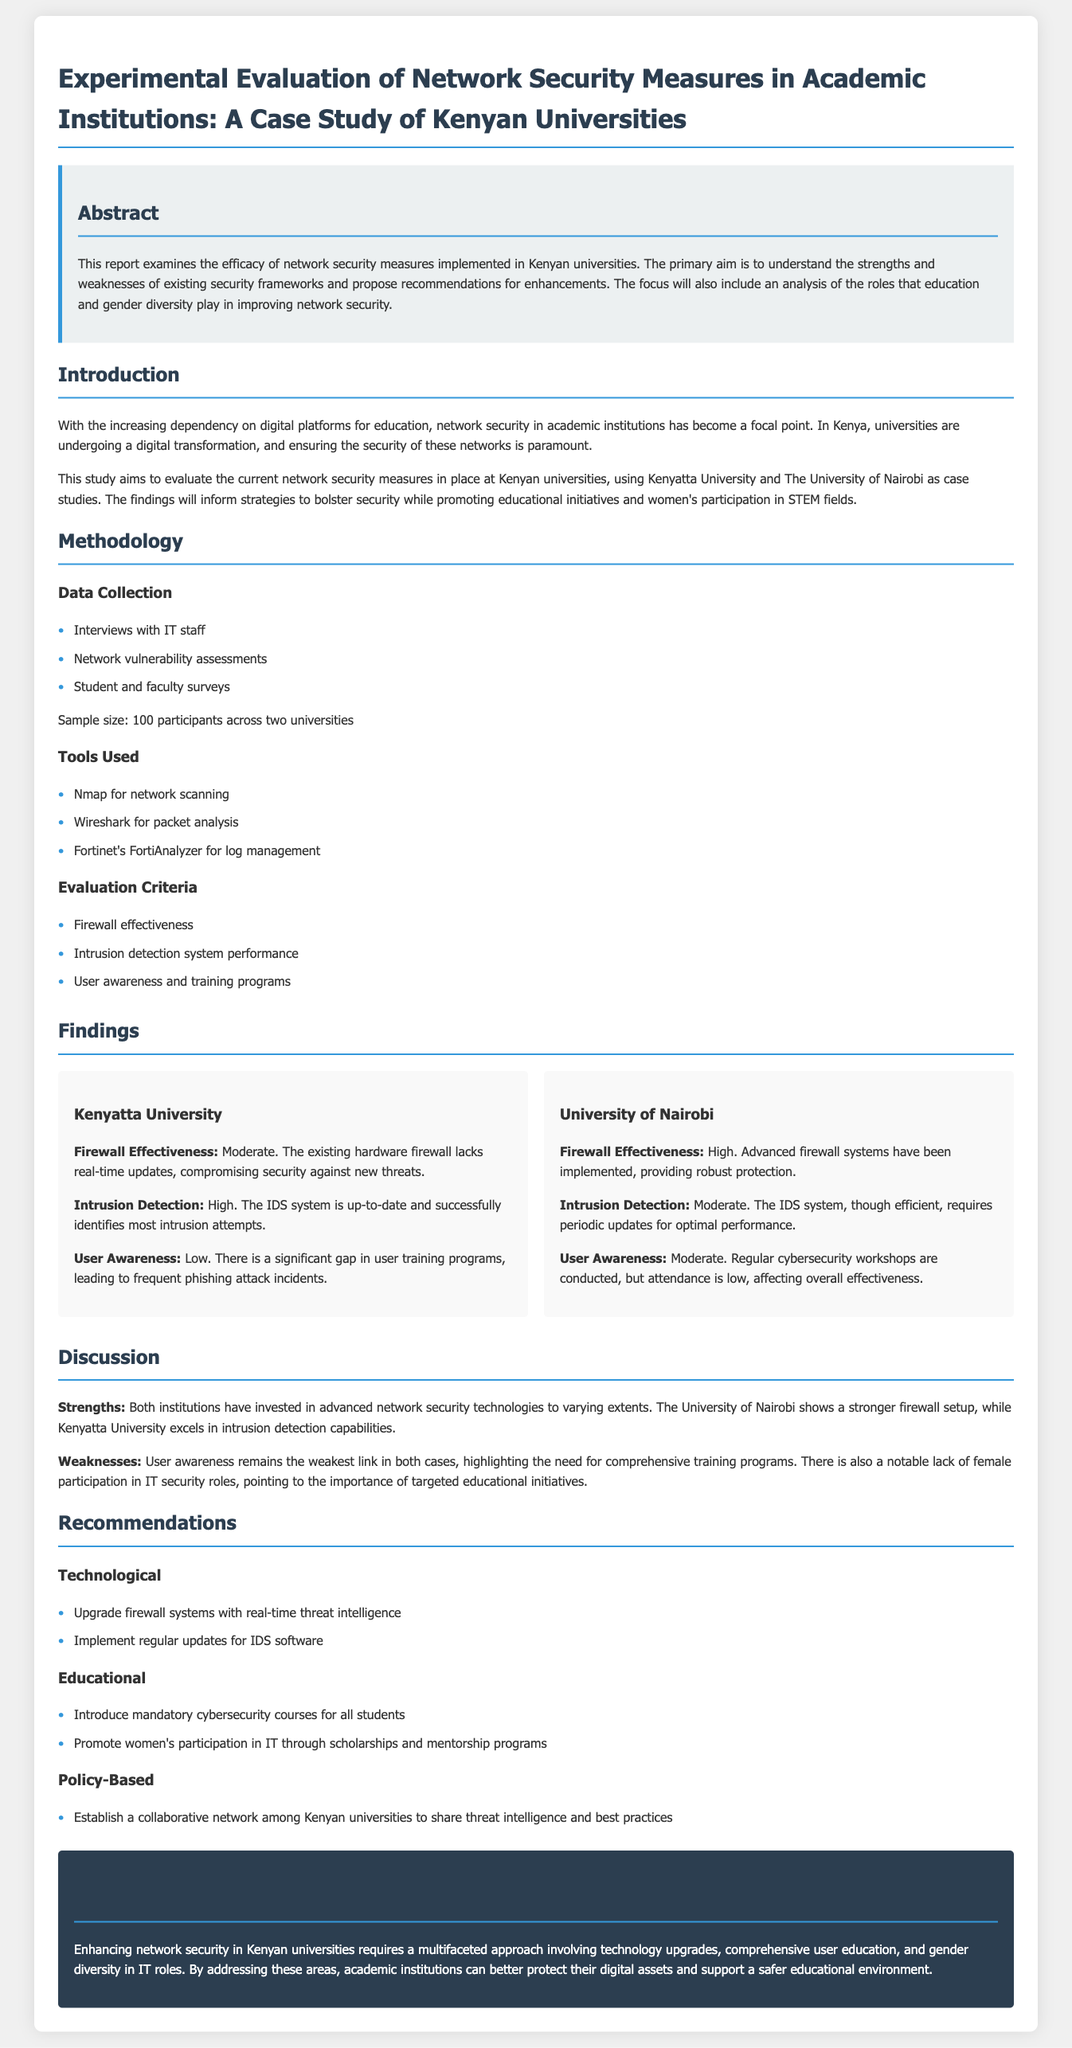What is the primary aim of the report? The primary aim is to understand the strengths and weaknesses of existing security frameworks and propose recommendations for enhancements.
Answer: understanding strengths and weaknesses How many participants were involved in the study? The sample size mentioned in the methodology section is 100 participants across two universities.
Answer: 100 participants What is the effectiveness rating of the firewall at Kenyatta University? The firewall effectiveness at Kenyatta University is rated as moderate.
Answer: Moderate What tools were used for network security evaluation? The tools listed include Nmap, Wireshark, and Fortinet's FortiAnalyzer for log management.
Answer: Nmap, Wireshark, Fortinet's FortiAnalyzer Which university has a higher user awareness according to the findings? Kenyatta University has a lower user awareness compared to the University of Nairobi, which is rated as moderate.
Answer: University of Nairobi What are the two recommended technological measures? The recommended technological measures include upgrading firewall systems with real-time threat intelligence and implementing regular updates for IDS software.
Answer: Upgrade firewall systems, implement regular updates What theme is emphasized in the educational recommendations? The theme emphasized is the promotion of women's participation in IT through scholarships and mentorship programs.
Answer: Promotion of women's participation What is a noted weakness in both universities regarding network security? A noted weakness is user awareness, as it remains the weakest link in both cases.
Answer: User awareness What is the background color for the conclusion section? The background color for the conclusion section is dark blue.
Answer: Dark blue 